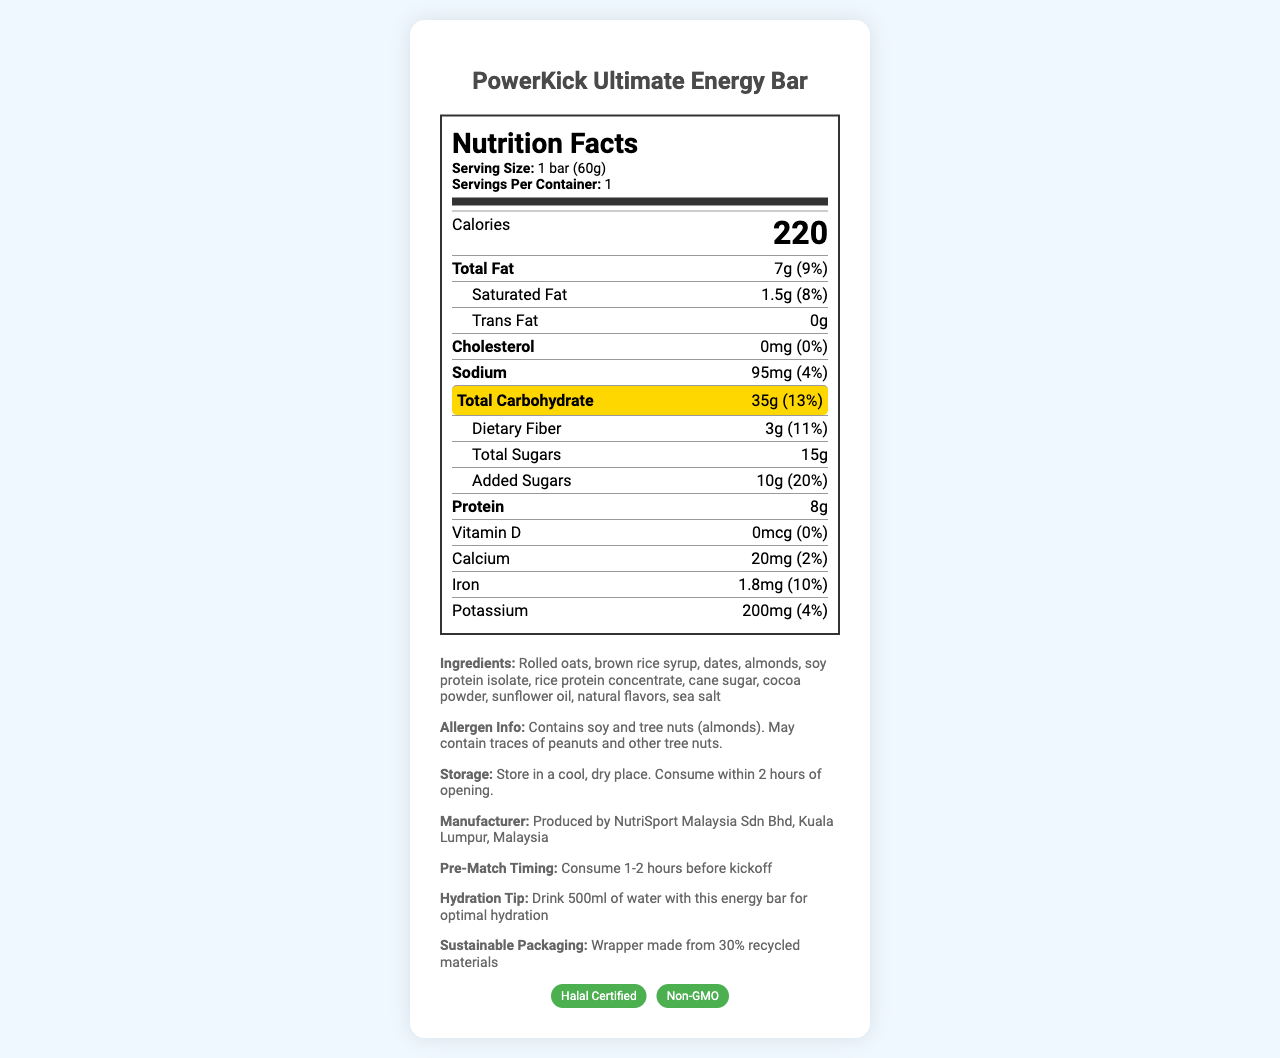What is the serving size of the PowerKick Ultimate Energy Bar? The document states in the serving info section: "Serving Size: 1 bar (60g)".
Answer: 1 bar (60g) How many grams of carbohydrates are in one serving of the energy bar? Under the nutrients list, it states: "Total Carbohydrate: 35g".
Answer: 35g What percentage of the daily value of added sugars does one bar contain? The document mentions under "Added Sugars": "10g (20%)".
Answer: 20% What is the total amount of protein in the energy bar? The document lists protein content as: "Protein: 8g".
Answer: 8g How many calories are in one serving? The "Calories" section shows: "Calories: 220".
Answer: 220 How much dietary fiber does the energy bar contain? A. 2g B. 3g C. 4g The nutrient list includes: "Dietary Fiber: 3g".
Answer: B. 3g Which of the following allergens are present in the energy bar? I. Peanuts II. Almonds III. Soy A. I and II B. II and III C. I and III The allergen info mentions: "Contains soy and tree nuts (almonds). May contain traces of peanuts and other tree nuts."
Answer: B. II and III Is the energy bar Halal certified? The certifications section includes a badge: "Halal Certified".
Answer: Yes Does the document provide information on storage instructions? It includes under storage: "Store in a cool, dry place. Consume within 2 hours of opening."
Answer: Yes Summarize the key information about the PowerKick Ultimate Energy Bar. This brief summary captures the essential aspects of nutritional content, allergens, certifications, storage instructions, and manufacturer details provided by the document.
Answer: The PowerKick Ultimate Energy Bar contains 220 calories per serving size of 1 bar (60g), providing 35g of carbohydrates, 7g of total fat, and 8g of protein. It has added sugars and dietary fiber, and is Halal Certified. It contains allergens such as soy and almonds. The bar should be consumed 1-2 hours before a match and stored in a cool, dry place, ideally consumed within 2 hours of opening. The product is manufactured by NutriSport Malaysia Sdn Bhd. What additional hydration tip is provided for consuming the energy bar? The additional info section advises: "Drink 500ml of water with this energy bar for optimal hydration."
Answer: Drink 500ml of water with this energy bar for optimal hydration What is the amount of potassium in one serving of the energy bar? Under the nutrient list, it states: "Potassium: 200mg (4%)".
Answer: 200mg Who is the manufacturer of the PowerKick Ultimate Energy Bar? This detail is provided under the manufacturer info section.
Answer: NutriSport Malaysia Sdn Bhd, Kuala Lumpur, Malaysia What is the main ingredient of the energy bar? The ingredient list starts with: "Rolled oats".
Answer: Rolled oats Based on the document, should the energy bar be consumed immediately before a match? The document specifies under pre-match timing: "Consume 1-2 hours before kickoff".
Answer: No What is the daily value percentage of calcium one bar provides? The nutrient list indicates: "Calcium: 20mg (2%)".
Answer: 2% What is the role of the sunflower oil in the product? The document lists sunflower oil as an ingredient but does not specify its role.
Answer: Not enough information 